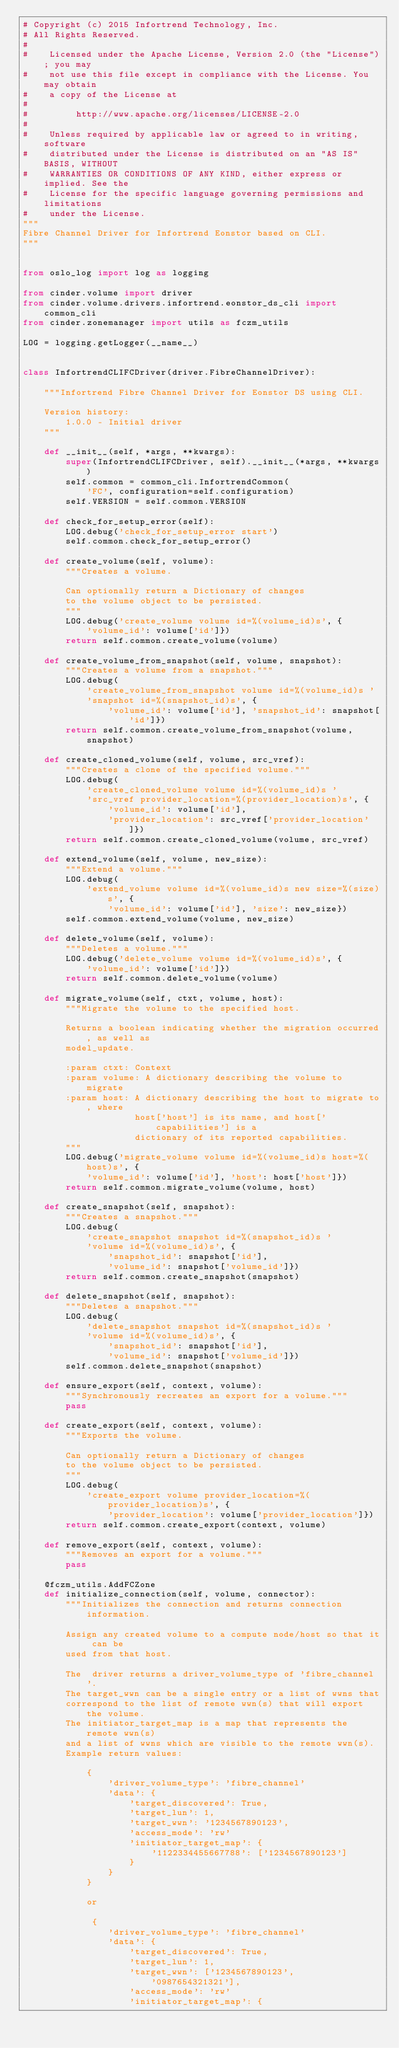Convert code to text. <code><loc_0><loc_0><loc_500><loc_500><_Python_># Copyright (c) 2015 Infortrend Technology, Inc.
# All Rights Reserved.
#
#    Licensed under the Apache License, Version 2.0 (the "License"); you may
#    not use this file except in compliance with the License. You may obtain
#    a copy of the License at
#
#         http://www.apache.org/licenses/LICENSE-2.0
#
#    Unless required by applicable law or agreed to in writing, software
#    distributed under the License is distributed on an "AS IS" BASIS, WITHOUT
#    WARRANTIES OR CONDITIONS OF ANY KIND, either express or implied. See the
#    License for the specific language governing permissions and limitations
#    under the License.
"""
Fibre Channel Driver for Infortrend Eonstor based on CLI.
"""


from oslo_log import log as logging

from cinder.volume import driver
from cinder.volume.drivers.infortrend.eonstor_ds_cli import common_cli
from cinder.zonemanager import utils as fczm_utils

LOG = logging.getLogger(__name__)


class InfortrendCLIFCDriver(driver.FibreChannelDriver):

    """Infortrend Fibre Channel Driver for Eonstor DS using CLI.

    Version history:
        1.0.0 - Initial driver
    """

    def __init__(self, *args, **kwargs):
        super(InfortrendCLIFCDriver, self).__init__(*args, **kwargs)
        self.common = common_cli.InfortrendCommon(
            'FC', configuration=self.configuration)
        self.VERSION = self.common.VERSION

    def check_for_setup_error(self):
        LOG.debug('check_for_setup_error start')
        self.common.check_for_setup_error()

    def create_volume(self, volume):
        """Creates a volume.

        Can optionally return a Dictionary of changes
        to the volume object to be persisted.
        """
        LOG.debug('create_volume volume id=%(volume_id)s', {
            'volume_id': volume['id']})
        return self.common.create_volume(volume)

    def create_volume_from_snapshot(self, volume, snapshot):
        """Creates a volume from a snapshot."""
        LOG.debug(
            'create_volume_from_snapshot volume id=%(volume_id)s '
            'snapshot id=%(snapshot_id)s', {
                'volume_id': volume['id'], 'snapshot_id': snapshot['id']})
        return self.common.create_volume_from_snapshot(volume, snapshot)

    def create_cloned_volume(self, volume, src_vref):
        """Creates a clone of the specified volume."""
        LOG.debug(
            'create_cloned_volume volume id=%(volume_id)s '
            'src_vref provider_location=%(provider_location)s', {
                'volume_id': volume['id'],
                'provider_location': src_vref['provider_location']})
        return self.common.create_cloned_volume(volume, src_vref)

    def extend_volume(self, volume, new_size):
        """Extend a volume."""
        LOG.debug(
            'extend_volume volume id=%(volume_id)s new size=%(size)s', {
                'volume_id': volume['id'], 'size': new_size})
        self.common.extend_volume(volume, new_size)

    def delete_volume(self, volume):
        """Deletes a volume."""
        LOG.debug('delete_volume volume id=%(volume_id)s', {
            'volume_id': volume['id']})
        return self.common.delete_volume(volume)

    def migrate_volume(self, ctxt, volume, host):
        """Migrate the volume to the specified host.

        Returns a boolean indicating whether the migration occurred, as well as
        model_update.

        :param ctxt: Context
        :param volume: A dictionary describing the volume to migrate
        :param host: A dictionary describing the host to migrate to, where
                     host['host'] is its name, and host['capabilities'] is a
                     dictionary of its reported capabilities.
        """
        LOG.debug('migrate_volume volume id=%(volume_id)s host=%(host)s', {
            'volume_id': volume['id'], 'host': host['host']})
        return self.common.migrate_volume(volume, host)

    def create_snapshot(self, snapshot):
        """Creates a snapshot."""
        LOG.debug(
            'create_snapshot snapshot id=%(snapshot_id)s '
            'volume id=%(volume_id)s', {
                'snapshot_id': snapshot['id'],
                'volume_id': snapshot['volume_id']})
        return self.common.create_snapshot(snapshot)

    def delete_snapshot(self, snapshot):
        """Deletes a snapshot."""
        LOG.debug(
            'delete_snapshot snapshot id=%(snapshot_id)s '
            'volume id=%(volume_id)s', {
                'snapshot_id': snapshot['id'],
                'volume_id': snapshot['volume_id']})
        self.common.delete_snapshot(snapshot)

    def ensure_export(self, context, volume):
        """Synchronously recreates an export for a volume."""
        pass

    def create_export(self, context, volume):
        """Exports the volume.

        Can optionally return a Dictionary of changes
        to the volume object to be persisted.
        """
        LOG.debug(
            'create_export volume provider_location=%(provider_location)s', {
                'provider_location': volume['provider_location']})
        return self.common.create_export(context, volume)

    def remove_export(self, context, volume):
        """Removes an export for a volume."""
        pass

    @fczm_utils.AddFCZone
    def initialize_connection(self, volume, connector):
        """Initializes the connection and returns connection information.

        Assign any created volume to a compute node/host so that it can be
        used from that host.

        The  driver returns a driver_volume_type of 'fibre_channel'.
        The target_wwn can be a single entry or a list of wwns that
        correspond to the list of remote wwn(s) that will export the volume.
        The initiator_target_map is a map that represents the remote wwn(s)
        and a list of wwns which are visible to the remote wwn(s).
        Example return values:

            {
                'driver_volume_type': 'fibre_channel'
                'data': {
                    'target_discovered': True,
                    'target_lun': 1,
                    'target_wwn': '1234567890123',
                    'access_mode': 'rw'
                    'initiator_target_map': {
                        '1122334455667788': ['1234567890123']
                    }
                }
            }

            or

             {
                'driver_volume_type': 'fibre_channel'
                'data': {
                    'target_discovered': True,
                    'target_lun': 1,
                    'target_wwn': ['1234567890123', '0987654321321'],
                    'access_mode': 'rw'
                    'initiator_target_map': {</code> 